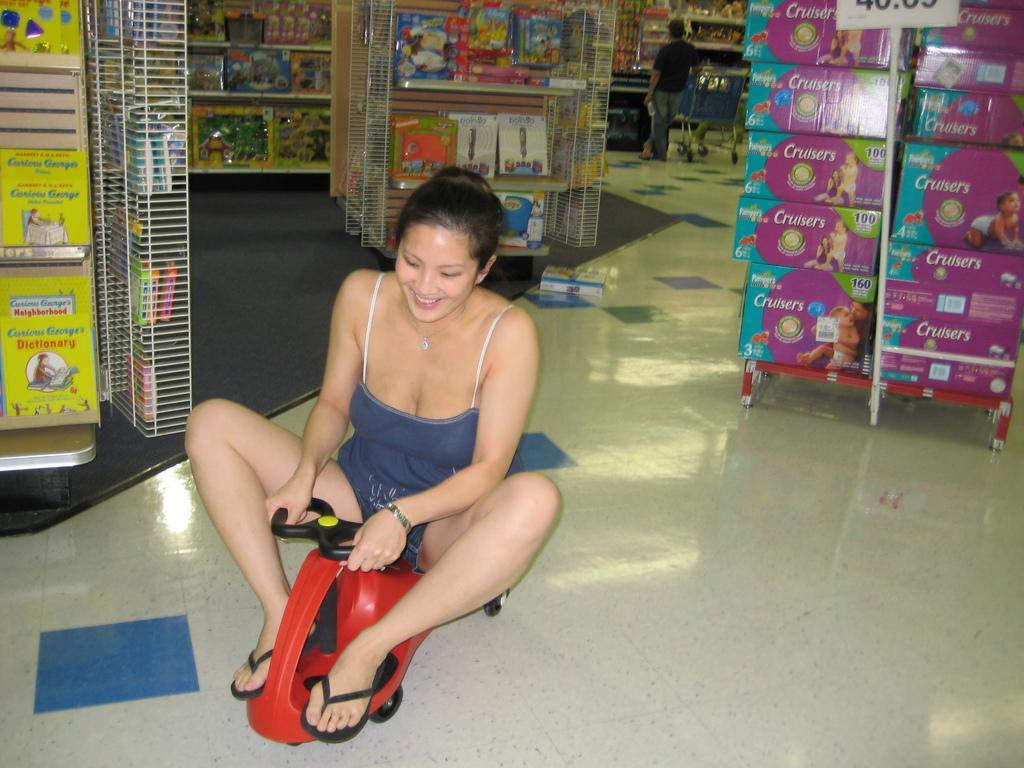How would you summarize this image in a sentence or two? In this image, we can see the interior view of a store. We can see some shelves with objects. There are a few people. Among them, we can see a lady riding a toy vehicle. We can also see a trolley. We can also see a board with some text. We can see the ground with an object. We can also see the mat. 